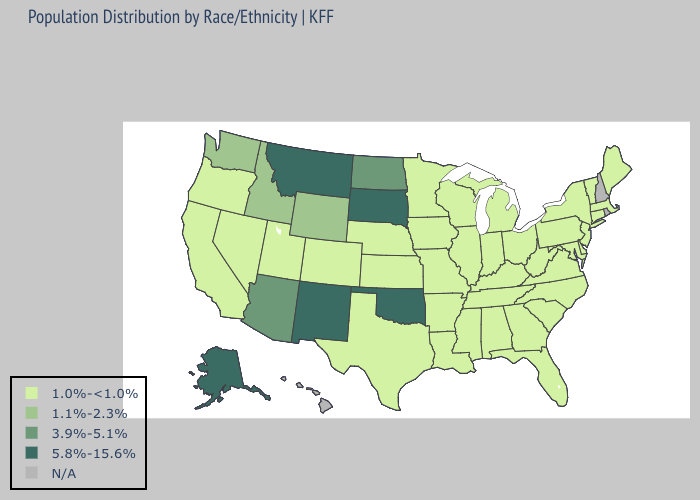Does Missouri have the highest value in the MidWest?
Keep it brief. No. What is the highest value in the MidWest ?
Give a very brief answer. 5.8%-15.6%. Name the states that have a value in the range 1.0%-<1.0%?
Be succinct. Alabama, Arkansas, California, Colorado, Connecticut, Delaware, Florida, Georgia, Illinois, Indiana, Iowa, Kansas, Kentucky, Louisiana, Maine, Maryland, Massachusetts, Michigan, Minnesota, Mississippi, Missouri, Nebraska, Nevada, New Jersey, New York, North Carolina, Ohio, Oregon, Pennsylvania, South Carolina, Tennessee, Texas, Utah, Vermont, Virginia, West Virginia, Wisconsin. What is the value of West Virginia?
Quick response, please. 1.0%-<1.0%. Which states have the lowest value in the MidWest?
Give a very brief answer. Illinois, Indiana, Iowa, Kansas, Michigan, Minnesota, Missouri, Nebraska, Ohio, Wisconsin. Does the first symbol in the legend represent the smallest category?
Give a very brief answer. Yes. Does Alaska have the lowest value in the USA?
Concise answer only. No. Which states have the lowest value in the Northeast?
Concise answer only. Connecticut, Maine, Massachusetts, New Jersey, New York, Pennsylvania, Vermont. What is the highest value in the Northeast ?
Concise answer only. 1.0%-<1.0%. What is the highest value in the MidWest ?
Answer briefly. 5.8%-15.6%. Name the states that have a value in the range 1.1%-2.3%?
Answer briefly. Idaho, Washington, Wyoming. 